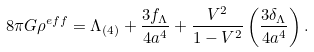Convert formula to latex. <formula><loc_0><loc_0><loc_500><loc_500>8 \pi G \rho ^ { e f f } = \Lambda _ { ( 4 ) } + \frac { 3 f _ { \Lambda } } { 4 a ^ { 4 } } + \frac { V ^ { 2 } } { 1 - V ^ { 2 } } \left ( \frac { 3 \delta _ { \Lambda } } { 4 a ^ { 4 } } \right ) .</formula> 